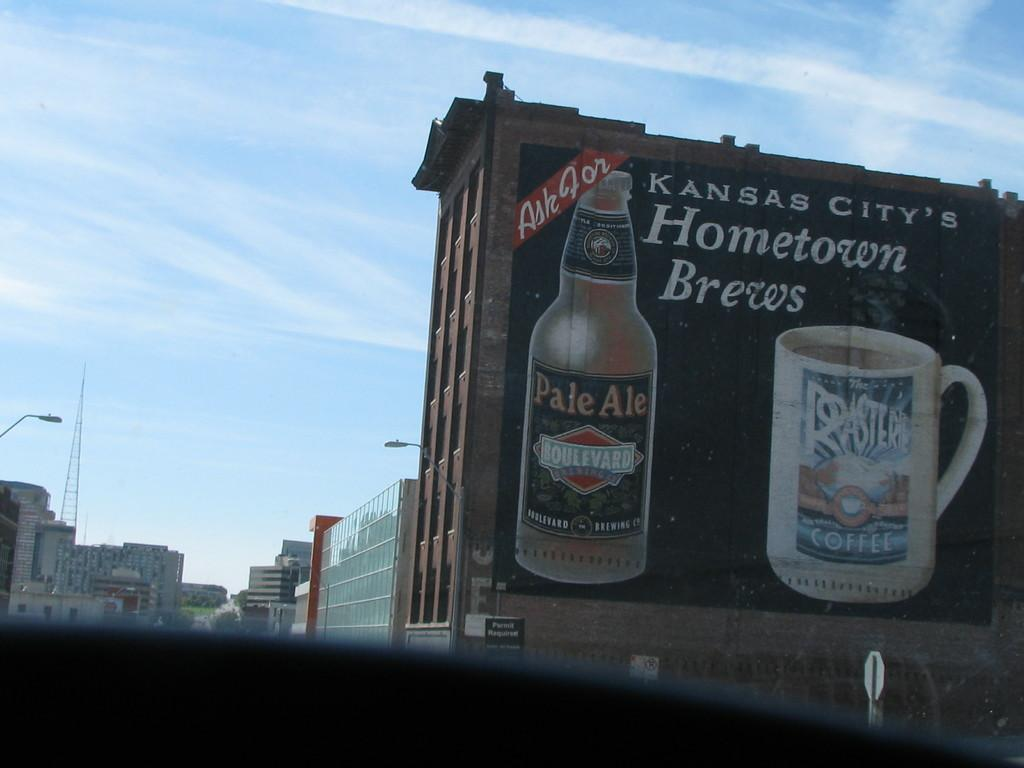<image>
Render a clear and concise summary of the photo. An advert with Hometown Brews written on it and a picture of a bottle of ale 